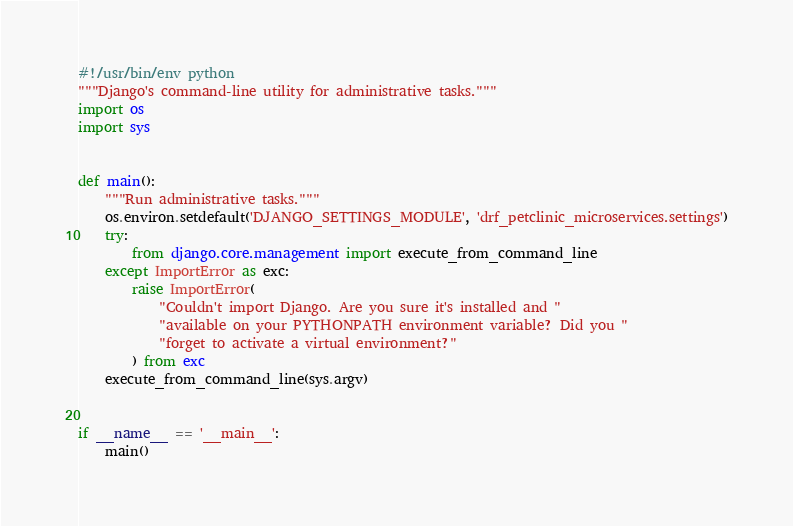Convert code to text. <code><loc_0><loc_0><loc_500><loc_500><_Python_>#!/usr/bin/env python
"""Django's command-line utility for administrative tasks."""
import os
import sys


def main():
    """Run administrative tasks."""
    os.environ.setdefault('DJANGO_SETTINGS_MODULE', 'drf_petclinic_microservices.settings')
    try:
        from django.core.management import execute_from_command_line
    except ImportError as exc:
        raise ImportError(
            "Couldn't import Django. Are you sure it's installed and "
            "available on your PYTHONPATH environment variable? Did you "
            "forget to activate a virtual environment?"
        ) from exc
    execute_from_command_line(sys.argv)


if __name__ == '__main__':
    main()
</code> 